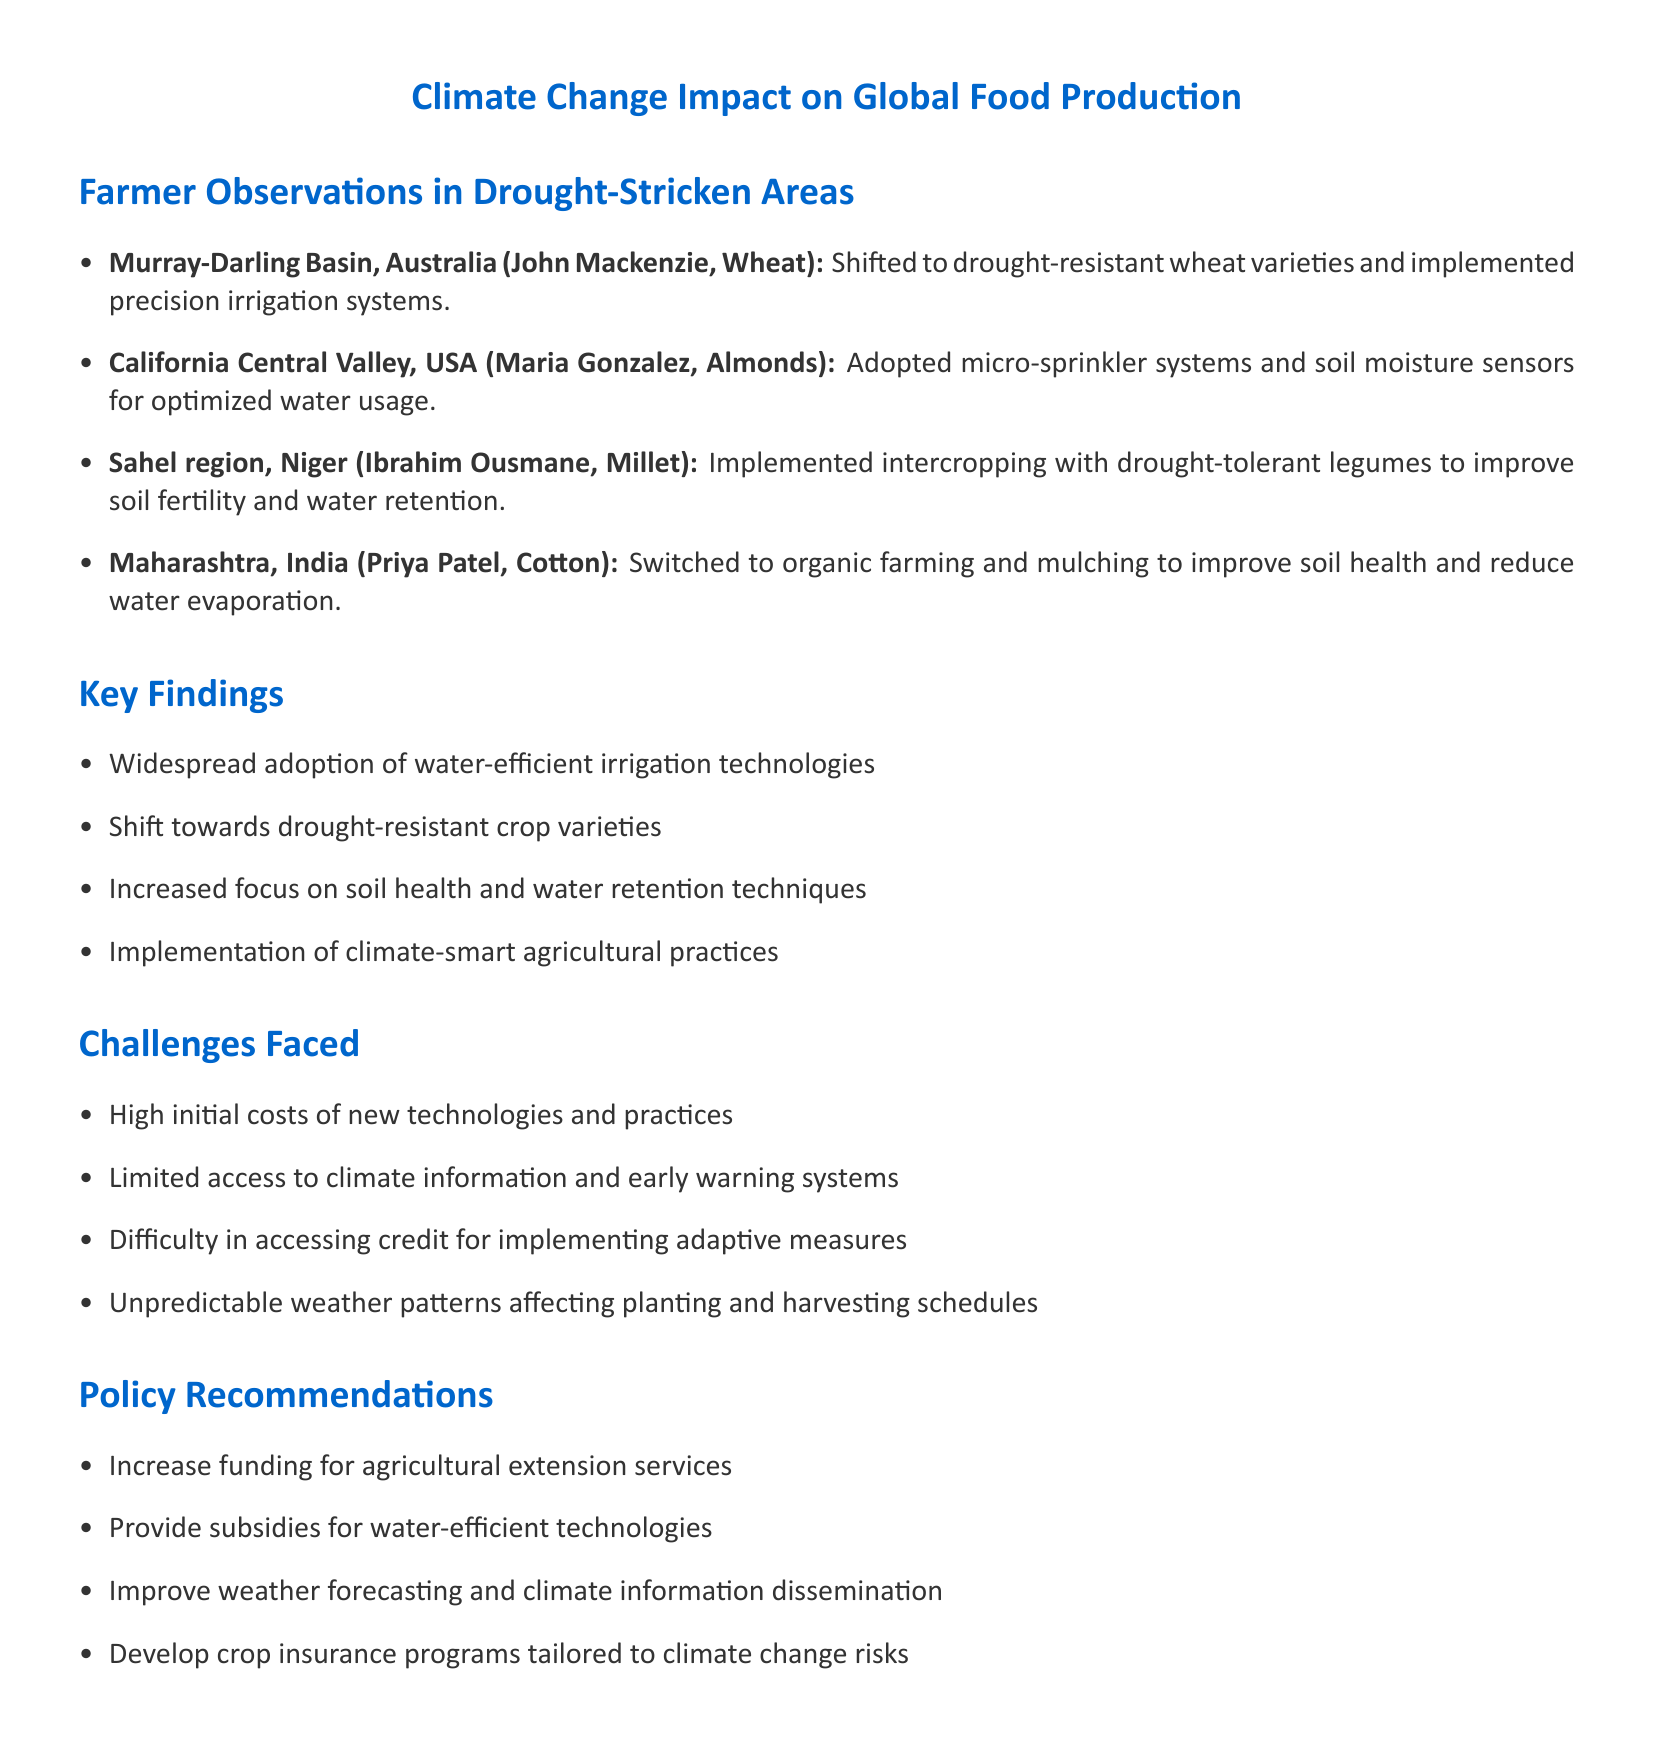What is the location of John Mackenzie? John Mackenzie is located in the Murray-Darling Basin, Australia.
Answer: Murray-Darling Basin, Australia What crop does Maria Gonzalez grow? Maria Gonzalez grows almonds in California Central Valley, USA.
Answer: Almonds What practice did Ibrahim Ousmane implement to improve soil fertility? Ibrahim Ousmane implemented intercropping techniques with drought-tolerant legumes.
Answer: Intercropping techniques with drought-tolerant legumes What is one of the key findings mentioned in the document? One key finding is the widespread adoption of water-efficient irrigation technologies.
Answer: Widespread adoption of water-efficient irrigation technologies What challenge do farmers face regarding technology costs? Farmers face high initial costs of new technologies and practices.
Answer: High initial costs What is a proposed policy recommendation related to technology? A proposed policy recommendation is to provide subsidies for water-efficient technologies.
Answer: Provide subsidies for water-efficient technologies How many farmers are interviewed in the document? The document includes observations from four farmers in drought-stricken areas.
Answer: Four farmers What crop did Priya Patel switch to organic farming for? Priya Patel switched to organic farming methods for cotton.
Answer: Cotton What is a focus area in the changing agricultural practices? There is an increased focus on soil health and water retention techniques.
Answer: Soil health and water retention techniques 